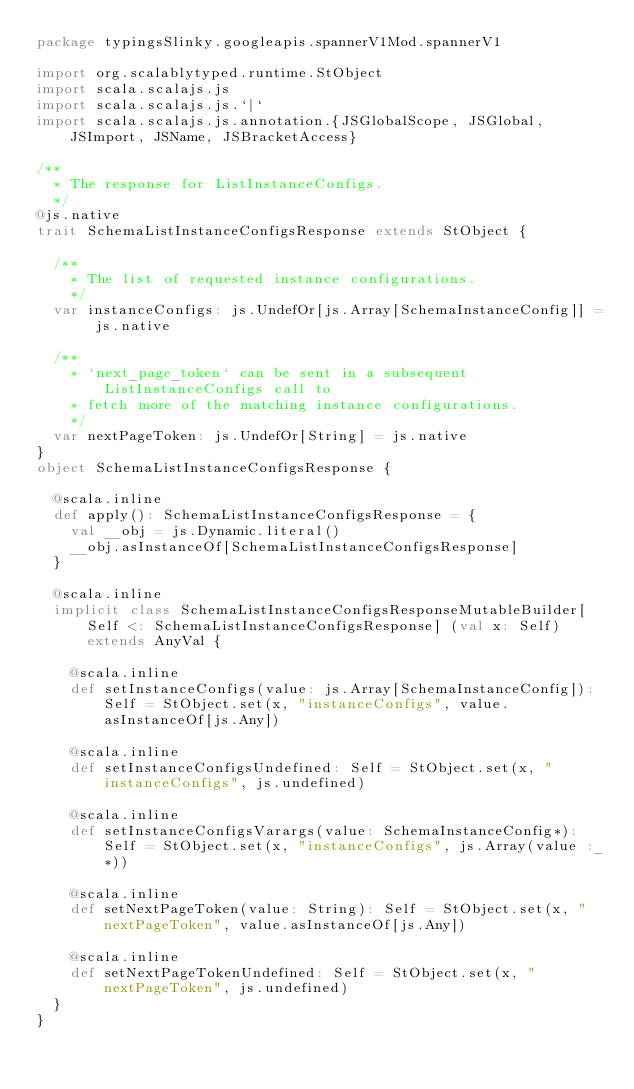Convert code to text. <code><loc_0><loc_0><loc_500><loc_500><_Scala_>package typingsSlinky.googleapis.spannerV1Mod.spannerV1

import org.scalablytyped.runtime.StObject
import scala.scalajs.js
import scala.scalajs.js.`|`
import scala.scalajs.js.annotation.{JSGlobalScope, JSGlobal, JSImport, JSName, JSBracketAccess}

/**
  * The response for ListInstanceConfigs.
  */
@js.native
trait SchemaListInstanceConfigsResponse extends StObject {
  
  /**
    * The list of requested instance configurations.
    */
  var instanceConfigs: js.UndefOr[js.Array[SchemaInstanceConfig]] = js.native
  
  /**
    * `next_page_token` can be sent in a subsequent ListInstanceConfigs call to
    * fetch more of the matching instance configurations.
    */
  var nextPageToken: js.UndefOr[String] = js.native
}
object SchemaListInstanceConfigsResponse {
  
  @scala.inline
  def apply(): SchemaListInstanceConfigsResponse = {
    val __obj = js.Dynamic.literal()
    __obj.asInstanceOf[SchemaListInstanceConfigsResponse]
  }
  
  @scala.inline
  implicit class SchemaListInstanceConfigsResponseMutableBuilder[Self <: SchemaListInstanceConfigsResponse] (val x: Self) extends AnyVal {
    
    @scala.inline
    def setInstanceConfigs(value: js.Array[SchemaInstanceConfig]): Self = StObject.set(x, "instanceConfigs", value.asInstanceOf[js.Any])
    
    @scala.inline
    def setInstanceConfigsUndefined: Self = StObject.set(x, "instanceConfigs", js.undefined)
    
    @scala.inline
    def setInstanceConfigsVarargs(value: SchemaInstanceConfig*): Self = StObject.set(x, "instanceConfigs", js.Array(value :_*))
    
    @scala.inline
    def setNextPageToken(value: String): Self = StObject.set(x, "nextPageToken", value.asInstanceOf[js.Any])
    
    @scala.inline
    def setNextPageTokenUndefined: Self = StObject.set(x, "nextPageToken", js.undefined)
  }
}
</code> 